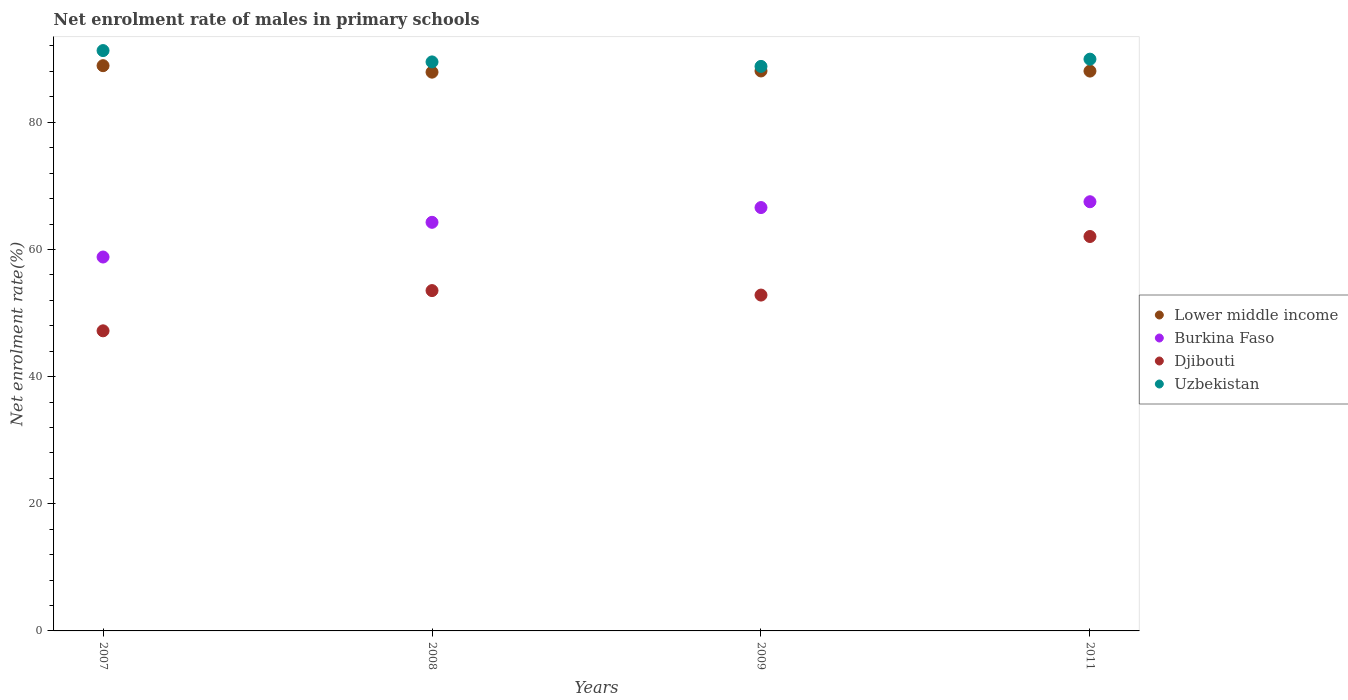Is the number of dotlines equal to the number of legend labels?
Provide a succinct answer. Yes. What is the net enrolment rate of males in primary schools in Djibouti in 2009?
Offer a very short reply. 52.82. Across all years, what is the maximum net enrolment rate of males in primary schools in Lower middle income?
Offer a terse response. 88.9. Across all years, what is the minimum net enrolment rate of males in primary schools in Djibouti?
Your answer should be compact. 47.2. In which year was the net enrolment rate of males in primary schools in Burkina Faso maximum?
Provide a succinct answer. 2011. What is the total net enrolment rate of males in primary schools in Uzbekistan in the graph?
Offer a terse response. 359.49. What is the difference between the net enrolment rate of males in primary schools in Lower middle income in 2008 and that in 2011?
Make the answer very short. -0.17. What is the difference between the net enrolment rate of males in primary schools in Djibouti in 2011 and the net enrolment rate of males in primary schools in Lower middle income in 2008?
Keep it short and to the point. -25.85. What is the average net enrolment rate of males in primary schools in Burkina Faso per year?
Your response must be concise. 64.29. In the year 2008, what is the difference between the net enrolment rate of males in primary schools in Uzbekistan and net enrolment rate of males in primary schools in Lower middle income?
Give a very brief answer. 1.61. In how many years, is the net enrolment rate of males in primary schools in Uzbekistan greater than 40 %?
Give a very brief answer. 4. What is the ratio of the net enrolment rate of males in primary schools in Djibouti in 2008 to that in 2011?
Make the answer very short. 0.86. What is the difference between the highest and the second highest net enrolment rate of males in primary schools in Djibouti?
Ensure brevity in your answer.  8.51. What is the difference between the highest and the lowest net enrolment rate of males in primary schools in Djibouti?
Your answer should be compact. 14.84. Is it the case that in every year, the sum of the net enrolment rate of males in primary schools in Lower middle income and net enrolment rate of males in primary schools in Burkina Faso  is greater than the sum of net enrolment rate of males in primary schools in Uzbekistan and net enrolment rate of males in primary schools in Djibouti?
Keep it short and to the point. No. Does the net enrolment rate of males in primary schools in Burkina Faso monotonically increase over the years?
Make the answer very short. Yes. Is the net enrolment rate of males in primary schools in Uzbekistan strictly less than the net enrolment rate of males in primary schools in Djibouti over the years?
Make the answer very short. No. How many years are there in the graph?
Your answer should be compact. 4. Are the values on the major ticks of Y-axis written in scientific E-notation?
Provide a succinct answer. No. Does the graph contain any zero values?
Your answer should be very brief. No. Where does the legend appear in the graph?
Provide a short and direct response. Center right. How many legend labels are there?
Offer a very short reply. 4. What is the title of the graph?
Your response must be concise. Net enrolment rate of males in primary schools. Does "Upper middle income" appear as one of the legend labels in the graph?
Offer a very short reply. No. What is the label or title of the Y-axis?
Give a very brief answer. Net enrolment rate(%). What is the Net enrolment rate(%) of Lower middle income in 2007?
Provide a succinct answer. 88.9. What is the Net enrolment rate(%) in Burkina Faso in 2007?
Ensure brevity in your answer.  58.81. What is the Net enrolment rate(%) of Djibouti in 2007?
Provide a succinct answer. 47.2. What is the Net enrolment rate(%) of Uzbekistan in 2007?
Your answer should be very brief. 91.28. What is the Net enrolment rate(%) of Lower middle income in 2008?
Your response must be concise. 87.88. What is the Net enrolment rate(%) of Burkina Faso in 2008?
Your answer should be compact. 64.27. What is the Net enrolment rate(%) of Djibouti in 2008?
Ensure brevity in your answer.  53.53. What is the Net enrolment rate(%) in Uzbekistan in 2008?
Provide a short and direct response. 89.5. What is the Net enrolment rate(%) in Lower middle income in 2009?
Keep it short and to the point. 88.07. What is the Net enrolment rate(%) in Burkina Faso in 2009?
Keep it short and to the point. 66.59. What is the Net enrolment rate(%) in Djibouti in 2009?
Ensure brevity in your answer.  52.82. What is the Net enrolment rate(%) in Uzbekistan in 2009?
Offer a terse response. 88.79. What is the Net enrolment rate(%) of Lower middle income in 2011?
Keep it short and to the point. 88.05. What is the Net enrolment rate(%) of Burkina Faso in 2011?
Provide a short and direct response. 67.5. What is the Net enrolment rate(%) of Djibouti in 2011?
Keep it short and to the point. 62.04. What is the Net enrolment rate(%) of Uzbekistan in 2011?
Ensure brevity in your answer.  89.93. Across all years, what is the maximum Net enrolment rate(%) of Lower middle income?
Offer a very short reply. 88.9. Across all years, what is the maximum Net enrolment rate(%) in Burkina Faso?
Provide a short and direct response. 67.5. Across all years, what is the maximum Net enrolment rate(%) of Djibouti?
Keep it short and to the point. 62.04. Across all years, what is the maximum Net enrolment rate(%) in Uzbekistan?
Keep it short and to the point. 91.28. Across all years, what is the minimum Net enrolment rate(%) of Lower middle income?
Provide a short and direct response. 87.88. Across all years, what is the minimum Net enrolment rate(%) in Burkina Faso?
Offer a terse response. 58.81. Across all years, what is the minimum Net enrolment rate(%) of Djibouti?
Provide a succinct answer. 47.2. Across all years, what is the minimum Net enrolment rate(%) in Uzbekistan?
Your response must be concise. 88.79. What is the total Net enrolment rate(%) of Lower middle income in the graph?
Provide a succinct answer. 352.91. What is the total Net enrolment rate(%) of Burkina Faso in the graph?
Your response must be concise. 257.17. What is the total Net enrolment rate(%) in Djibouti in the graph?
Your answer should be very brief. 215.59. What is the total Net enrolment rate(%) of Uzbekistan in the graph?
Your answer should be very brief. 359.49. What is the difference between the Net enrolment rate(%) in Lower middle income in 2007 and that in 2008?
Ensure brevity in your answer.  1.02. What is the difference between the Net enrolment rate(%) of Burkina Faso in 2007 and that in 2008?
Offer a very short reply. -5.46. What is the difference between the Net enrolment rate(%) in Djibouti in 2007 and that in 2008?
Make the answer very short. -6.33. What is the difference between the Net enrolment rate(%) of Uzbekistan in 2007 and that in 2008?
Your answer should be very brief. 1.78. What is the difference between the Net enrolment rate(%) in Lower middle income in 2007 and that in 2009?
Your answer should be compact. 0.83. What is the difference between the Net enrolment rate(%) in Burkina Faso in 2007 and that in 2009?
Your response must be concise. -7.78. What is the difference between the Net enrolment rate(%) of Djibouti in 2007 and that in 2009?
Your response must be concise. -5.62. What is the difference between the Net enrolment rate(%) in Uzbekistan in 2007 and that in 2009?
Your answer should be compact. 2.49. What is the difference between the Net enrolment rate(%) in Lower middle income in 2007 and that in 2011?
Ensure brevity in your answer.  0.85. What is the difference between the Net enrolment rate(%) of Burkina Faso in 2007 and that in 2011?
Offer a terse response. -8.69. What is the difference between the Net enrolment rate(%) in Djibouti in 2007 and that in 2011?
Your response must be concise. -14.84. What is the difference between the Net enrolment rate(%) of Uzbekistan in 2007 and that in 2011?
Offer a very short reply. 1.35. What is the difference between the Net enrolment rate(%) of Lower middle income in 2008 and that in 2009?
Give a very brief answer. -0.19. What is the difference between the Net enrolment rate(%) in Burkina Faso in 2008 and that in 2009?
Make the answer very short. -2.32. What is the difference between the Net enrolment rate(%) in Djibouti in 2008 and that in 2009?
Offer a very short reply. 0.7. What is the difference between the Net enrolment rate(%) of Uzbekistan in 2008 and that in 2009?
Give a very brief answer. 0.7. What is the difference between the Net enrolment rate(%) of Lower middle income in 2008 and that in 2011?
Your answer should be compact. -0.17. What is the difference between the Net enrolment rate(%) in Burkina Faso in 2008 and that in 2011?
Your response must be concise. -3.24. What is the difference between the Net enrolment rate(%) in Djibouti in 2008 and that in 2011?
Provide a short and direct response. -8.51. What is the difference between the Net enrolment rate(%) in Uzbekistan in 2008 and that in 2011?
Ensure brevity in your answer.  -0.43. What is the difference between the Net enrolment rate(%) in Lower middle income in 2009 and that in 2011?
Make the answer very short. 0.02. What is the difference between the Net enrolment rate(%) in Burkina Faso in 2009 and that in 2011?
Your response must be concise. -0.92. What is the difference between the Net enrolment rate(%) in Djibouti in 2009 and that in 2011?
Your response must be concise. -9.21. What is the difference between the Net enrolment rate(%) in Uzbekistan in 2009 and that in 2011?
Your response must be concise. -1.14. What is the difference between the Net enrolment rate(%) in Lower middle income in 2007 and the Net enrolment rate(%) in Burkina Faso in 2008?
Offer a terse response. 24.64. What is the difference between the Net enrolment rate(%) of Lower middle income in 2007 and the Net enrolment rate(%) of Djibouti in 2008?
Provide a short and direct response. 35.38. What is the difference between the Net enrolment rate(%) of Lower middle income in 2007 and the Net enrolment rate(%) of Uzbekistan in 2008?
Provide a short and direct response. -0.59. What is the difference between the Net enrolment rate(%) of Burkina Faso in 2007 and the Net enrolment rate(%) of Djibouti in 2008?
Your answer should be compact. 5.28. What is the difference between the Net enrolment rate(%) in Burkina Faso in 2007 and the Net enrolment rate(%) in Uzbekistan in 2008?
Ensure brevity in your answer.  -30.69. What is the difference between the Net enrolment rate(%) in Djibouti in 2007 and the Net enrolment rate(%) in Uzbekistan in 2008?
Provide a short and direct response. -42.3. What is the difference between the Net enrolment rate(%) of Lower middle income in 2007 and the Net enrolment rate(%) of Burkina Faso in 2009?
Make the answer very short. 22.32. What is the difference between the Net enrolment rate(%) in Lower middle income in 2007 and the Net enrolment rate(%) in Djibouti in 2009?
Your response must be concise. 36.08. What is the difference between the Net enrolment rate(%) in Lower middle income in 2007 and the Net enrolment rate(%) in Uzbekistan in 2009?
Ensure brevity in your answer.  0.11. What is the difference between the Net enrolment rate(%) of Burkina Faso in 2007 and the Net enrolment rate(%) of Djibouti in 2009?
Offer a terse response. 5.99. What is the difference between the Net enrolment rate(%) of Burkina Faso in 2007 and the Net enrolment rate(%) of Uzbekistan in 2009?
Your answer should be compact. -29.98. What is the difference between the Net enrolment rate(%) of Djibouti in 2007 and the Net enrolment rate(%) of Uzbekistan in 2009?
Your answer should be very brief. -41.59. What is the difference between the Net enrolment rate(%) in Lower middle income in 2007 and the Net enrolment rate(%) in Burkina Faso in 2011?
Offer a very short reply. 21.4. What is the difference between the Net enrolment rate(%) in Lower middle income in 2007 and the Net enrolment rate(%) in Djibouti in 2011?
Your response must be concise. 26.87. What is the difference between the Net enrolment rate(%) of Lower middle income in 2007 and the Net enrolment rate(%) of Uzbekistan in 2011?
Provide a short and direct response. -1.02. What is the difference between the Net enrolment rate(%) in Burkina Faso in 2007 and the Net enrolment rate(%) in Djibouti in 2011?
Your answer should be very brief. -3.23. What is the difference between the Net enrolment rate(%) in Burkina Faso in 2007 and the Net enrolment rate(%) in Uzbekistan in 2011?
Provide a succinct answer. -31.12. What is the difference between the Net enrolment rate(%) of Djibouti in 2007 and the Net enrolment rate(%) of Uzbekistan in 2011?
Give a very brief answer. -42.73. What is the difference between the Net enrolment rate(%) of Lower middle income in 2008 and the Net enrolment rate(%) of Burkina Faso in 2009?
Your response must be concise. 21.3. What is the difference between the Net enrolment rate(%) in Lower middle income in 2008 and the Net enrolment rate(%) in Djibouti in 2009?
Give a very brief answer. 35.06. What is the difference between the Net enrolment rate(%) in Lower middle income in 2008 and the Net enrolment rate(%) in Uzbekistan in 2009?
Make the answer very short. -0.91. What is the difference between the Net enrolment rate(%) in Burkina Faso in 2008 and the Net enrolment rate(%) in Djibouti in 2009?
Provide a short and direct response. 11.44. What is the difference between the Net enrolment rate(%) in Burkina Faso in 2008 and the Net enrolment rate(%) in Uzbekistan in 2009?
Your answer should be very brief. -24.52. What is the difference between the Net enrolment rate(%) of Djibouti in 2008 and the Net enrolment rate(%) of Uzbekistan in 2009?
Offer a terse response. -35.26. What is the difference between the Net enrolment rate(%) of Lower middle income in 2008 and the Net enrolment rate(%) of Burkina Faso in 2011?
Offer a very short reply. 20.38. What is the difference between the Net enrolment rate(%) in Lower middle income in 2008 and the Net enrolment rate(%) in Djibouti in 2011?
Ensure brevity in your answer.  25.85. What is the difference between the Net enrolment rate(%) in Lower middle income in 2008 and the Net enrolment rate(%) in Uzbekistan in 2011?
Your response must be concise. -2.04. What is the difference between the Net enrolment rate(%) in Burkina Faso in 2008 and the Net enrolment rate(%) in Djibouti in 2011?
Provide a succinct answer. 2.23. What is the difference between the Net enrolment rate(%) of Burkina Faso in 2008 and the Net enrolment rate(%) of Uzbekistan in 2011?
Ensure brevity in your answer.  -25.66. What is the difference between the Net enrolment rate(%) of Djibouti in 2008 and the Net enrolment rate(%) of Uzbekistan in 2011?
Your answer should be very brief. -36.4. What is the difference between the Net enrolment rate(%) in Lower middle income in 2009 and the Net enrolment rate(%) in Burkina Faso in 2011?
Keep it short and to the point. 20.57. What is the difference between the Net enrolment rate(%) of Lower middle income in 2009 and the Net enrolment rate(%) of Djibouti in 2011?
Provide a succinct answer. 26.04. What is the difference between the Net enrolment rate(%) in Lower middle income in 2009 and the Net enrolment rate(%) in Uzbekistan in 2011?
Provide a short and direct response. -1.86. What is the difference between the Net enrolment rate(%) in Burkina Faso in 2009 and the Net enrolment rate(%) in Djibouti in 2011?
Keep it short and to the point. 4.55. What is the difference between the Net enrolment rate(%) in Burkina Faso in 2009 and the Net enrolment rate(%) in Uzbekistan in 2011?
Keep it short and to the point. -23.34. What is the difference between the Net enrolment rate(%) in Djibouti in 2009 and the Net enrolment rate(%) in Uzbekistan in 2011?
Provide a succinct answer. -37.1. What is the average Net enrolment rate(%) in Lower middle income per year?
Your answer should be compact. 88.23. What is the average Net enrolment rate(%) of Burkina Faso per year?
Ensure brevity in your answer.  64.29. What is the average Net enrolment rate(%) in Djibouti per year?
Keep it short and to the point. 53.9. What is the average Net enrolment rate(%) of Uzbekistan per year?
Your response must be concise. 89.87. In the year 2007, what is the difference between the Net enrolment rate(%) in Lower middle income and Net enrolment rate(%) in Burkina Faso?
Your answer should be compact. 30.1. In the year 2007, what is the difference between the Net enrolment rate(%) in Lower middle income and Net enrolment rate(%) in Djibouti?
Provide a succinct answer. 41.7. In the year 2007, what is the difference between the Net enrolment rate(%) in Lower middle income and Net enrolment rate(%) in Uzbekistan?
Offer a terse response. -2.37. In the year 2007, what is the difference between the Net enrolment rate(%) in Burkina Faso and Net enrolment rate(%) in Djibouti?
Your answer should be very brief. 11.61. In the year 2007, what is the difference between the Net enrolment rate(%) in Burkina Faso and Net enrolment rate(%) in Uzbekistan?
Provide a succinct answer. -32.47. In the year 2007, what is the difference between the Net enrolment rate(%) in Djibouti and Net enrolment rate(%) in Uzbekistan?
Offer a terse response. -44.08. In the year 2008, what is the difference between the Net enrolment rate(%) of Lower middle income and Net enrolment rate(%) of Burkina Faso?
Make the answer very short. 23.62. In the year 2008, what is the difference between the Net enrolment rate(%) of Lower middle income and Net enrolment rate(%) of Djibouti?
Make the answer very short. 34.36. In the year 2008, what is the difference between the Net enrolment rate(%) in Lower middle income and Net enrolment rate(%) in Uzbekistan?
Your answer should be very brief. -1.61. In the year 2008, what is the difference between the Net enrolment rate(%) of Burkina Faso and Net enrolment rate(%) of Djibouti?
Provide a short and direct response. 10.74. In the year 2008, what is the difference between the Net enrolment rate(%) in Burkina Faso and Net enrolment rate(%) in Uzbekistan?
Ensure brevity in your answer.  -25.23. In the year 2008, what is the difference between the Net enrolment rate(%) of Djibouti and Net enrolment rate(%) of Uzbekistan?
Ensure brevity in your answer.  -35.97. In the year 2009, what is the difference between the Net enrolment rate(%) of Lower middle income and Net enrolment rate(%) of Burkina Faso?
Your response must be concise. 21.48. In the year 2009, what is the difference between the Net enrolment rate(%) in Lower middle income and Net enrolment rate(%) in Djibouti?
Your response must be concise. 35.25. In the year 2009, what is the difference between the Net enrolment rate(%) in Lower middle income and Net enrolment rate(%) in Uzbekistan?
Your response must be concise. -0.72. In the year 2009, what is the difference between the Net enrolment rate(%) of Burkina Faso and Net enrolment rate(%) of Djibouti?
Make the answer very short. 13.77. In the year 2009, what is the difference between the Net enrolment rate(%) of Burkina Faso and Net enrolment rate(%) of Uzbekistan?
Ensure brevity in your answer.  -22.2. In the year 2009, what is the difference between the Net enrolment rate(%) of Djibouti and Net enrolment rate(%) of Uzbekistan?
Keep it short and to the point. -35.97. In the year 2011, what is the difference between the Net enrolment rate(%) in Lower middle income and Net enrolment rate(%) in Burkina Faso?
Ensure brevity in your answer.  20.55. In the year 2011, what is the difference between the Net enrolment rate(%) of Lower middle income and Net enrolment rate(%) of Djibouti?
Give a very brief answer. 26.02. In the year 2011, what is the difference between the Net enrolment rate(%) of Lower middle income and Net enrolment rate(%) of Uzbekistan?
Your answer should be very brief. -1.88. In the year 2011, what is the difference between the Net enrolment rate(%) in Burkina Faso and Net enrolment rate(%) in Djibouti?
Provide a short and direct response. 5.47. In the year 2011, what is the difference between the Net enrolment rate(%) of Burkina Faso and Net enrolment rate(%) of Uzbekistan?
Your response must be concise. -22.42. In the year 2011, what is the difference between the Net enrolment rate(%) in Djibouti and Net enrolment rate(%) in Uzbekistan?
Keep it short and to the point. -27.89. What is the ratio of the Net enrolment rate(%) in Lower middle income in 2007 to that in 2008?
Your answer should be very brief. 1.01. What is the ratio of the Net enrolment rate(%) in Burkina Faso in 2007 to that in 2008?
Your response must be concise. 0.92. What is the ratio of the Net enrolment rate(%) in Djibouti in 2007 to that in 2008?
Provide a succinct answer. 0.88. What is the ratio of the Net enrolment rate(%) of Uzbekistan in 2007 to that in 2008?
Your answer should be compact. 1.02. What is the ratio of the Net enrolment rate(%) in Lower middle income in 2007 to that in 2009?
Make the answer very short. 1.01. What is the ratio of the Net enrolment rate(%) in Burkina Faso in 2007 to that in 2009?
Provide a succinct answer. 0.88. What is the ratio of the Net enrolment rate(%) of Djibouti in 2007 to that in 2009?
Keep it short and to the point. 0.89. What is the ratio of the Net enrolment rate(%) in Uzbekistan in 2007 to that in 2009?
Your answer should be very brief. 1.03. What is the ratio of the Net enrolment rate(%) of Lower middle income in 2007 to that in 2011?
Provide a short and direct response. 1.01. What is the ratio of the Net enrolment rate(%) of Burkina Faso in 2007 to that in 2011?
Your answer should be very brief. 0.87. What is the ratio of the Net enrolment rate(%) in Djibouti in 2007 to that in 2011?
Provide a short and direct response. 0.76. What is the ratio of the Net enrolment rate(%) in Lower middle income in 2008 to that in 2009?
Provide a short and direct response. 1. What is the ratio of the Net enrolment rate(%) in Burkina Faso in 2008 to that in 2009?
Your answer should be compact. 0.97. What is the ratio of the Net enrolment rate(%) in Djibouti in 2008 to that in 2009?
Provide a short and direct response. 1.01. What is the ratio of the Net enrolment rate(%) of Uzbekistan in 2008 to that in 2009?
Give a very brief answer. 1.01. What is the ratio of the Net enrolment rate(%) of Burkina Faso in 2008 to that in 2011?
Make the answer very short. 0.95. What is the ratio of the Net enrolment rate(%) in Djibouti in 2008 to that in 2011?
Your answer should be very brief. 0.86. What is the ratio of the Net enrolment rate(%) of Uzbekistan in 2008 to that in 2011?
Provide a succinct answer. 1. What is the ratio of the Net enrolment rate(%) of Lower middle income in 2009 to that in 2011?
Provide a succinct answer. 1. What is the ratio of the Net enrolment rate(%) in Burkina Faso in 2009 to that in 2011?
Your response must be concise. 0.99. What is the ratio of the Net enrolment rate(%) in Djibouti in 2009 to that in 2011?
Provide a short and direct response. 0.85. What is the ratio of the Net enrolment rate(%) in Uzbekistan in 2009 to that in 2011?
Offer a terse response. 0.99. What is the difference between the highest and the second highest Net enrolment rate(%) of Lower middle income?
Keep it short and to the point. 0.83. What is the difference between the highest and the second highest Net enrolment rate(%) of Burkina Faso?
Make the answer very short. 0.92. What is the difference between the highest and the second highest Net enrolment rate(%) in Djibouti?
Give a very brief answer. 8.51. What is the difference between the highest and the second highest Net enrolment rate(%) in Uzbekistan?
Make the answer very short. 1.35. What is the difference between the highest and the lowest Net enrolment rate(%) of Lower middle income?
Provide a short and direct response. 1.02. What is the difference between the highest and the lowest Net enrolment rate(%) in Burkina Faso?
Offer a terse response. 8.69. What is the difference between the highest and the lowest Net enrolment rate(%) of Djibouti?
Your answer should be very brief. 14.84. What is the difference between the highest and the lowest Net enrolment rate(%) of Uzbekistan?
Your answer should be very brief. 2.49. 